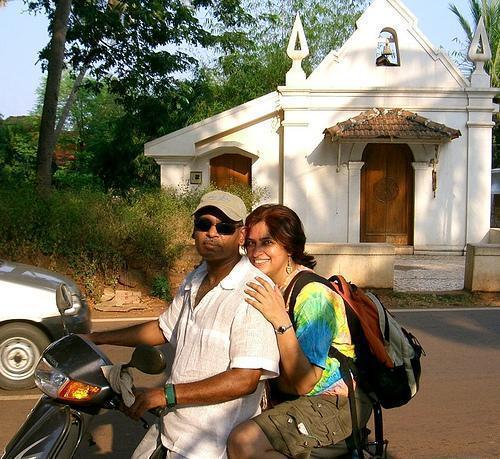What season is most likely?
Select the accurate answer and provide explanation: 'Answer: answer
Rationale: rationale.'
Options: Spring, summer, autumn, winter. Answer: summer.
Rationale: The season is summer. 